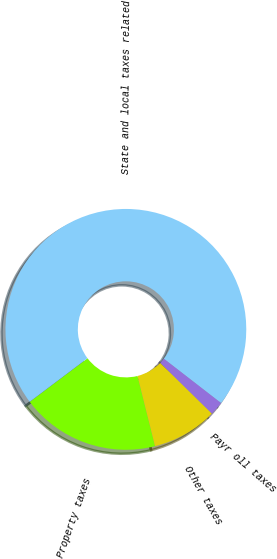<chart> <loc_0><loc_0><loc_500><loc_500><pie_chart><fcel>Property taxes<fcel>State and local taxes related<fcel>Payr oll taxes<fcel>Other taxes<nl><fcel>18.62%<fcel>70.76%<fcel>1.86%<fcel>8.75%<nl></chart> 